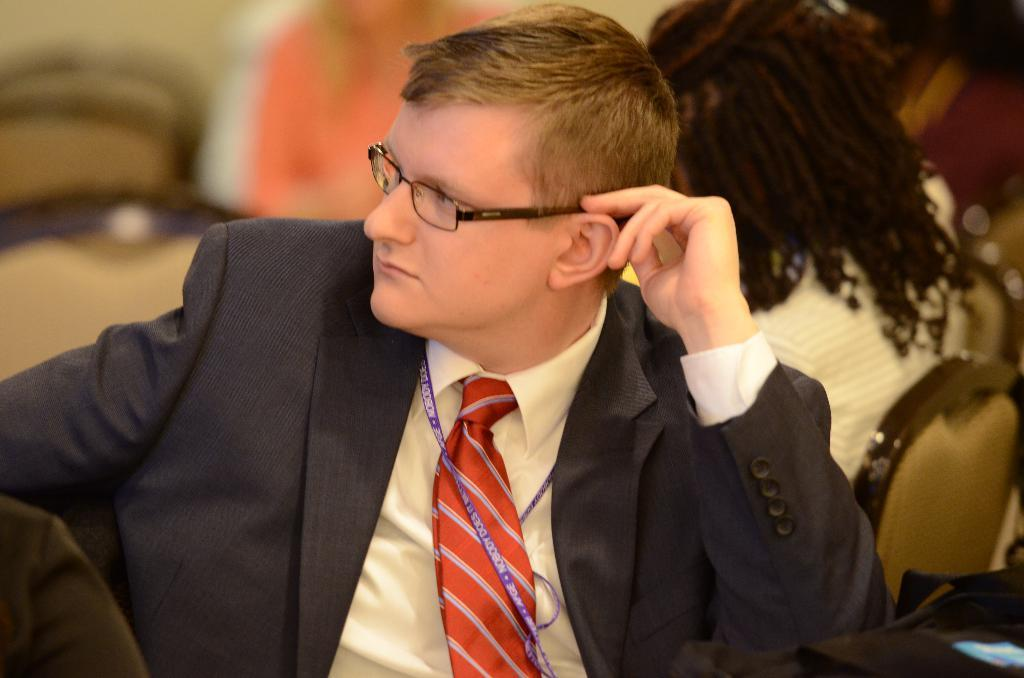What is the man in the image doing? The man is sitting in the image. What is the man wearing? The man is wearing clothes and spectacles. Can you describe the people in the background of the image? The background is blurred, so it is difficult to see the people clearly. What is the overall appearance of the background in the image? The background is blurred. What type of tray is the man holding in the image? There is no tray present in the image; the man is simply sitting. Can you describe the lamp that is illuminating the scene in the image? There is no lamp present in the image; the lighting is not described in the provided facts. 